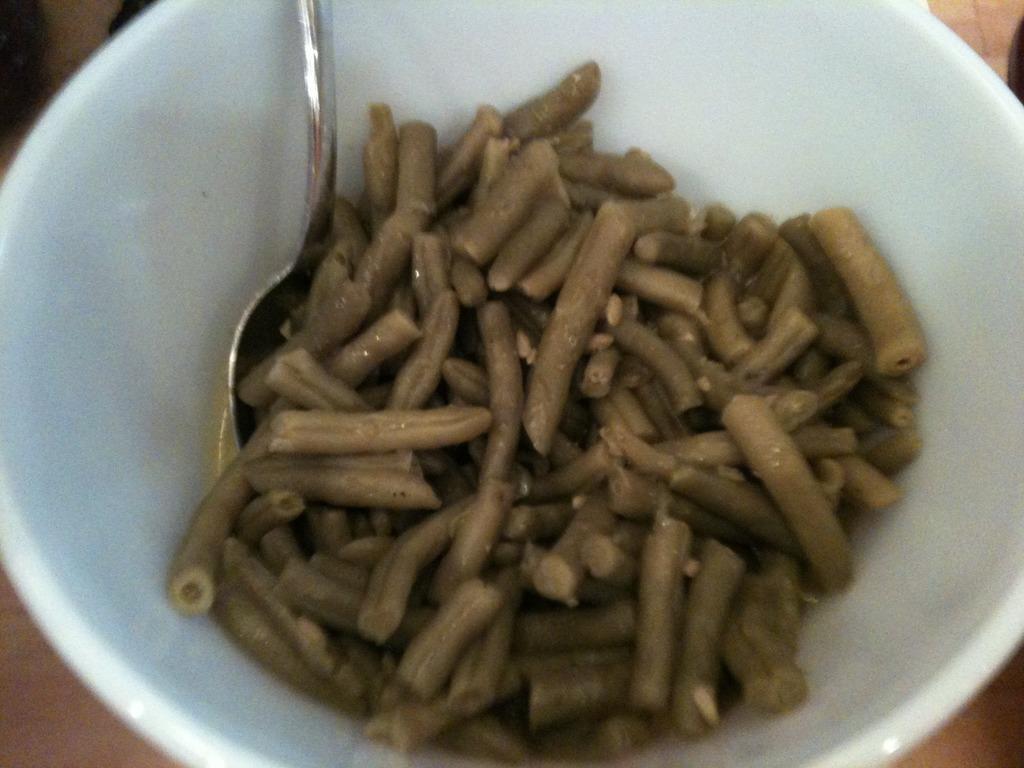How would you summarize this image in a sentence or two? In this picture there is a bowl which is kept on the table. In that bowl we can see the stone and beans. 